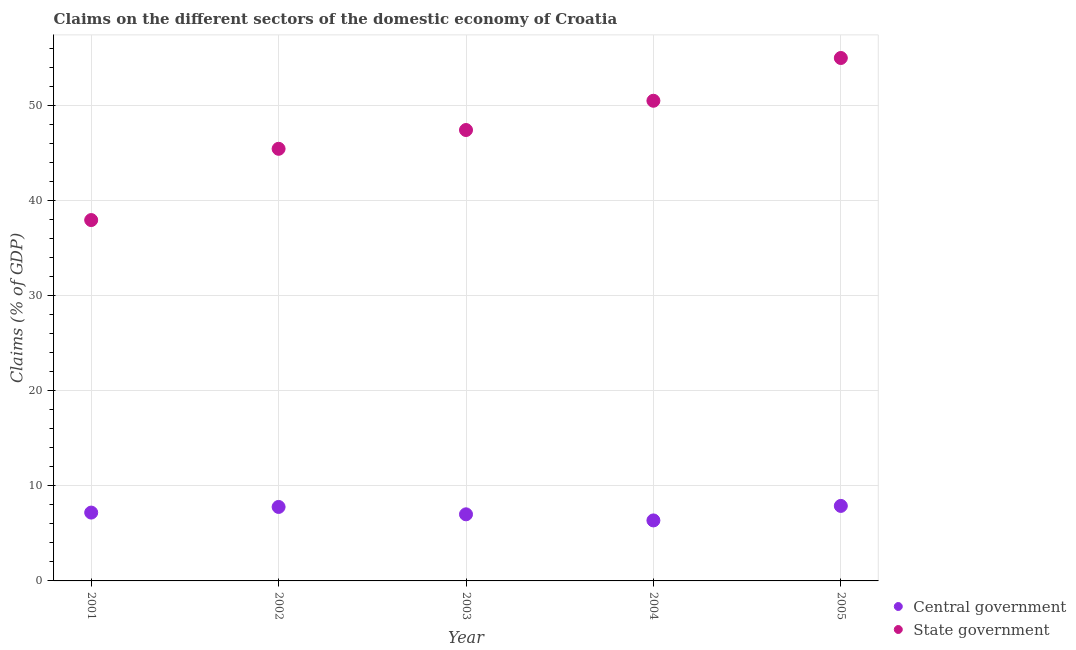How many different coloured dotlines are there?
Your response must be concise. 2. Is the number of dotlines equal to the number of legend labels?
Ensure brevity in your answer.  Yes. What is the claims on state government in 2001?
Give a very brief answer. 37.93. Across all years, what is the maximum claims on state government?
Provide a succinct answer. 54.96. Across all years, what is the minimum claims on central government?
Ensure brevity in your answer.  6.36. In which year was the claims on state government maximum?
Make the answer very short. 2005. What is the total claims on state government in the graph?
Keep it short and to the point. 236.17. What is the difference between the claims on state government in 2003 and that in 2005?
Your response must be concise. -7.57. What is the difference between the claims on central government in 2003 and the claims on state government in 2002?
Provide a short and direct response. -38.42. What is the average claims on central government per year?
Your response must be concise. 7.24. In the year 2001, what is the difference between the claims on state government and claims on central government?
Provide a short and direct response. 30.75. In how many years, is the claims on state government greater than 16 %?
Offer a terse response. 5. What is the ratio of the claims on state government in 2001 to that in 2003?
Give a very brief answer. 0.8. Is the claims on central government in 2001 less than that in 2004?
Ensure brevity in your answer.  No. Is the difference between the claims on state government in 2002 and 2003 greater than the difference between the claims on central government in 2002 and 2003?
Ensure brevity in your answer.  No. What is the difference between the highest and the second highest claims on state government?
Your answer should be very brief. 4.49. What is the difference between the highest and the lowest claims on central government?
Offer a terse response. 1.53. In how many years, is the claims on central government greater than the average claims on central government taken over all years?
Give a very brief answer. 2. Is the sum of the claims on central government in 2001 and 2004 greater than the maximum claims on state government across all years?
Offer a very short reply. No. Does the claims on central government monotonically increase over the years?
Your answer should be very brief. No. Is the claims on state government strictly less than the claims on central government over the years?
Offer a very short reply. No. What is the difference between two consecutive major ticks on the Y-axis?
Your response must be concise. 10. Does the graph contain any zero values?
Your response must be concise. No. How are the legend labels stacked?
Your answer should be compact. Vertical. What is the title of the graph?
Your response must be concise. Claims on the different sectors of the domestic economy of Croatia. Does "Short-term debt" appear as one of the legend labels in the graph?
Your response must be concise. No. What is the label or title of the Y-axis?
Ensure brevity in your answer.  Claims (% of GDP). What is the Claims (% of GDP) of Central government in 2001?
Your answer should be very brief. 7.18. What is the Claims (% of GDP) in State government in 2001?
Give a very brief answer. 37.93. What is the Claims (% of GDP) of Central government in 2002?
Your answer should be compact. 7.78. What is the Claims (% of GDP) of State government in 2002?
Ensure brevity in your answer.  45.42. What is the Claims (% of GDP) of Central government in 2003?
Offer a very short reply. 7. What is the Claims (% of GDP) of State government in 2003?
Give a very brief answer. 47.39. What is the Claims (% of GDP) of Central government in 2004?
Your answer should be compact. 6.36. What is the Claims (% of GDP) in State government in 2004?
Your answer should be very brief. 50.47. What is the Claims (% of GDP) in Central government in 2005?
Offer a terse response. 7.88. What is the Claims (% of GDP) in State government in 2005?
Make the answer very short. 54.96. Across all years, what is the maximum Claims (% of GDP) in Central government?
Give a very brief answer. 7.88. Across all years, what is the maximum Claims (% of GDP) in State government?
Offer a very short reply. 54.96. Across all years, what is the minimum Claims (% of GDP) of Central government?
Offer a very short reply. 6.36. Across all years, what is the minimum Claims (% of GDP) in State government?
Keep it short and to the point. 37.93. What is the total Claims (% of GDP) of Central government in the graph?
Provide a succinct answer. 36.2. What is the total Claims (% of GDP) in State government in the graph?
Your answer should be compact. 236.17. What is the difference between the Claims (% of GDP) in Central government in 2001 and that in 2002?
Your answer should be compact. -0.59. What is the difference between the Claims (% of GDP) in State government in 2001 and that in 2002?
Ensure brevity in your answer.  -7.49. What is the difference between the Claims (% of GDP) in Central government in 2001 and that in 2003?
Provide a short and direct response. 0.18. What is the difference between the Claims (% of GDP) of State government in 2001 and that in 2003?
Give a very brief answer. -9.46. What is the difference between the Claims (% of GDP) of Central government in 2001 and that in 2004?
Make the answer very short. 0.82. What is the difference between the Claims (% of GDP) in State government in 2001 and that in 2004?
Your answer should be very brief. -12.54. What is the difference between the Claims (% of GDP) of Central government in 2001 and that in 2005?
Give a very brief answer. -0.7. What is the difference between the Claims (% of GDP) of State government in 2001 and that in 2005?
Ensure brevity in your answer.  -17.03. What is the difference between the Claims (% of GDP) of Central government in 2002 and that in 2003?
Offer a very short reply. 0.78. What is the difference between the Claims (% of GDP) in State government in 2002 and that in 2003?
Offer a very short reply. -1.98. What is the difference between the Claims (% of GDP) in Central government in 2002 and that in 2004?
Your response must be concise. 1.42. What is the difference between the Claims (% of GDP) of State government in 2002 and that in 2004?
Provide a succinct answer. -5.05. What is the difference between the Claims (% of GDP) of Central government in 2002 and that in 2005?
Your answer should be compact. -0.11. What is the difference between the Claims (% of GDP) of State government in 2002 and that in 2005?
Your response must be concise. -9.54. What is the difference between the Claims (% of GDP) in Central government in 2003 and that in 2004?
Provide a short and direct response. 0.64. What is the difference between the Claims (% of GDP) in State government in 2003 and that in 2004?
Your response must be concise. -3.07. What is the difference between the Claims (% of GDP) in Central government in 2003 and that in 2005?
Provide a short and direct response. -0.88. What is the difference between the Claims (% of GDP) of State government in 2003 and that in 2005?
Keep it short and to the point. -7.57. What is the difference between the Claims (% of GDP) of Central government in 2004 and that in 2005?
Offer a terse response. -1.53. What is the difference between the Claims (% of GDP) in State government in 2004 and that in 2005?
Offer a very short reply. -4.49. What is the difference between the Claims (% of GDP) of Central government in 2001 and the Claims (% of GDP) of State government in 2002?
Your answer should be compact. -38.23. What is the difference between the Claims (% of GDP) in Central government in 2001 and the Claims (% of GDP) in State government in 2003?
Provide a succinct answer. -40.21. What is the difference between the Claims (% of GDP) of Central government in 2001 and the Claims (% of GDP) of State government in 2004?
Keep it short and to the point. -43.28. What is the difference between the Claims (% of GDP) in Central government in 2001 and the Claims (% of GDP) in State government in 2005?
Your response must be concise. -47.78. What is the difference between the Claims (% of GDP) in Central government in 2002 and the Claims (% of GDP) in State government in 2003?
Ensure brevity in your answer.  -39.62. What is the difference between the Claims (% of GDP) in Central government in 2002 and the Claims (% of GDP) in State government in 2004?
Make the answer very short. -42.69. What is the difference between the Claims (% of GDP) in Central government in 2002 and the Claims (% of GDP) in State government in 2005?
Your answer should be very brief. -47.19. What is the difference between the Claims (% of GDP) of Central government in 2003 and the Claims (% of GDP) of State government in 2004?
Your response must be concise. -43.47. What is the difference between the Claims (% of GDP) in Central government in 2003 and the Claims (% of GDP) in State government in 2005?
Provide a succinct answer. -47.96. What is the difference between the Claims (% of GDP) of Central government in 2004 and the Claims (% of GDP) of State government in 2005?
Your answer should be very brief. -48.6. What is the average Claims (% of GDP) in Central government per year?
Ensure brevity in your answer.  7.24. What is the average Claims (% of GDP) of State government per year?
Your answer should be very brief. 47.23. In the year 2001, what is the difference between the Claims (% of GDP) of Central government and Claims (% of GDP) of State government?
Keep it short and to the point. -30.75. In the year 2002, what is the difference between the Claims (% of GDP) in Central government and Claims (% of GDP) in State government?
Offer a very short reply. -37.64. In the year 2003, what is the difference between the Claims (% of GDP) of Central government and Claims (% of GDP) of State government?
Give a very brief answer. -40.39. In the year 2004, what is the difference between the Claims (% of GDP) of Central government and Claims (% of GDP) of State government?
Offer a very short reply. -44.11. In the year 2005, what is the difference between the Claims (% of GDP) of Central government and Claims (% of GDP) of State government?
Ensure brevity in your answer.  -47.08. What is the ratio of the Claims (% of GDP) of Central government in 2001 to that in 2002?
Give a very brief answer. 0.92. What is the ratio of the Claims (% of GDP) of State government in 2001 to that in 2002?
Your answer should be very brief. 0.84. What is the ratio of the Claims (% of GDP) of Central government in 2001 to that in 2003?
Ensure brevity in your answer.  1.03. What is the ratio of the Claims (% of GDP) in State government in 2001 to that in 2003?
Offer a terse response. 0.8. What is the ratio of the Claims (% of GDP) in Central government in 2001 to that in 2004?
Your response must be concise. 1.13. What is the ratio of the Claims (% of GDP) of State government in 2001 to that in 2004?
Make the answer very short. 0.75. What is the ratio of the Claims (% of GDP) in Central government in 2001 to that in 2005?
Ensure brevity in your answer.  0.91. What is the ratio of the Claims (% of GDP) of State government in 2001 to that in 2005?
Give a very brief answer. 0.69. What is the ratio of the Claims (% of GDP) in Central government in 2002 to that in 2003?
Offer a very short reply. 1.11. What is the ratio of the Claims (% of GDP) in State government in 2002 to that in 2003?
Ensure brevity in your answer.  0.96. What is the ratio of the Claims (% of GDP) in Central government in 2002 to that in 2004?
Your response must be concise. 1.22. What is the ratio of the Claims (% of GDP) in State government in 2002 to that in 2004?
Make the answer very short. 0.9. What is the ratio of the Claims (% of GDP) of Central government in 2002 to that in 2005?
Give a very brief answer. 0.99. What is the ratio of the Claims (% of GDP) of State government in 2002 to that in 2005?
Your response must be concise. 0.83. What is the ratio of the Claims (% of GDP) in Central government in 2003 to that in 2004?
Offer a terse response. 1.1. What is the ratio of the Claims (% of GDP) in State government in 2003 to that in 2004?
Offer a very short reply. 0.94. What is the ratio of the Claims (% of GDP) in Central government in 2003 to that in 2005?
Your response must be concise. 0.89. What is the ratio of the Claims (% of GDP) of State government in 2003 to that in 2005?
Offer a terse response. 0.86. What is the ratio of the Claims (% of GDP) in Central government in 2004 to that in 2005?
Provide a short and direct response. 0.81. What is the ratio of the Claims (% of GDP) in State government in 2004 to that in 2005?
Ensure brevity in your answer.  0.92. What is the difference between the highest and the second highest Claims (% of GDP) of Central government?
Keep it short and to the point. 0.11. What is the difference between the highest and the second highest Claims (% of GDP) of State government?
Make the answer very short. 4.49. What is the difference between the highest and the lowest Claims (% of GDP) in Central government?
Offer a very short reply. 1.53. What is the difference between the highest and the lowest Claims (% of GDP) of State government?
Make the answer very short. 17.03. 